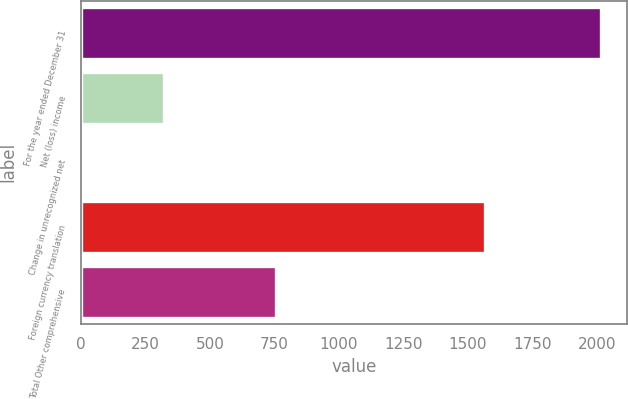<chart> <loc_0><loc_0><loc_500><loc_500><bar_chart><fcel>For the year ended December 31<fcel>Net (loss) income<fcel>Change in unrecognized net<fcel>Foreign currency translation<fcel>Total Other comprehensive<nl><fcel>2015<fcel>322<fcel>10<fcel>1566<fcel>754<nl></chart> 